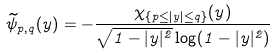<formula> <loc_0><loc_0><loc_500><loc_500>\widetilde { \psi } _ { p , q } ( y ) = - \frac { \chi _ { \{ p \leq | y | \leq q \} } ( y ) } { \sqrt { 1 - | y | ^ { 2 } } \log ( 1 - | y | ^ { 2 } ) }</formula> 